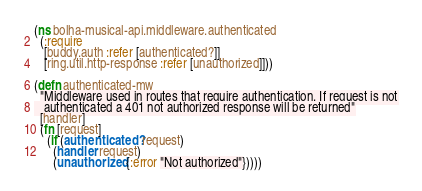<code> <loc_0><loc_0><loc_500><loc_500><_Clojure_>(ns bolha-musical-api.middleware.authenticated
  (:require
   [buddy.auth :refer [authenticated?]]
   [ring.util.http-response :refer [unauthorized]]))

(defn authenticated-mw
  "Middleware used in routes that require authentication. If request is not
   authenticated a 401 not authorized response will be returned"
  [handler]
  (fn [request]
    (if (authenticated? request)
      (handler request)
      (unauthorized {:error "Not authorized"}))))
</code> 